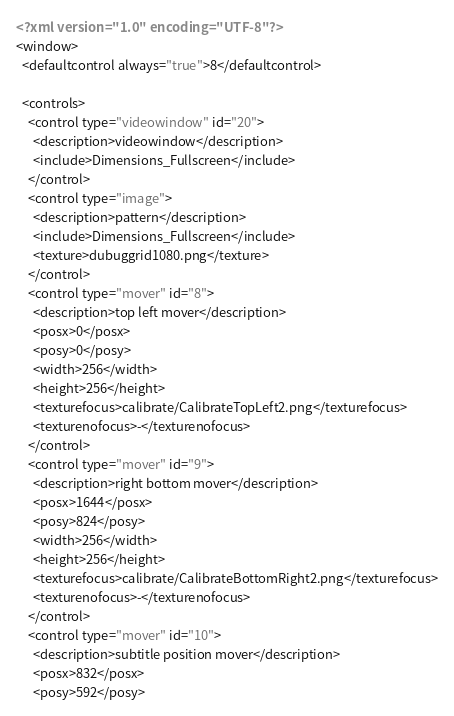Convert code to text. <code><loc_0><loc_0><loc_500><loc_500><_XML_><?xml version="1.0" encoding="UTF-8"?>
<window>
  <defaultcontrol always="true">8</defaultcontrol>
  
  <controls>
    <control type="videowindow" id="20">
      <description>videowindow</description>
      <include>Dimensions_Fullscreen</include>
    </control>
	<control type="image">
      <description>pattern</description>
      <include>Dimensions_Fullscreen</include>
	  <texture>dubuggrid1080.png</texture>
    </control>
    <control type="mover" id="8">
      <description>top left mover</description>
      <posx>0</posx>
      <posy>0</posy>
      <width>256</width>
      <height>256</height>
      <texturefocus>calibrate/CalibrateTopLeft2.png</texturefocus>
      <texturenofocus>-</texturenofocus>
    </control>
    <control type="mover" id="9">
      <description>right bottom mover</description>
      <posx>1644</posx>
      <posy>824</posy>
      <width>256</width>
      <height>256</height>
      <texturefocus>calibrate/CalibrateBottomRight2.png</texturefocus>
      <texturenofocus>-</texturenofocus>
    </control>
    <control type="mover" id="10">
      <description>subtitle position mover</description>
      <posx>832</posx>
      <posy>592</posy></code> 